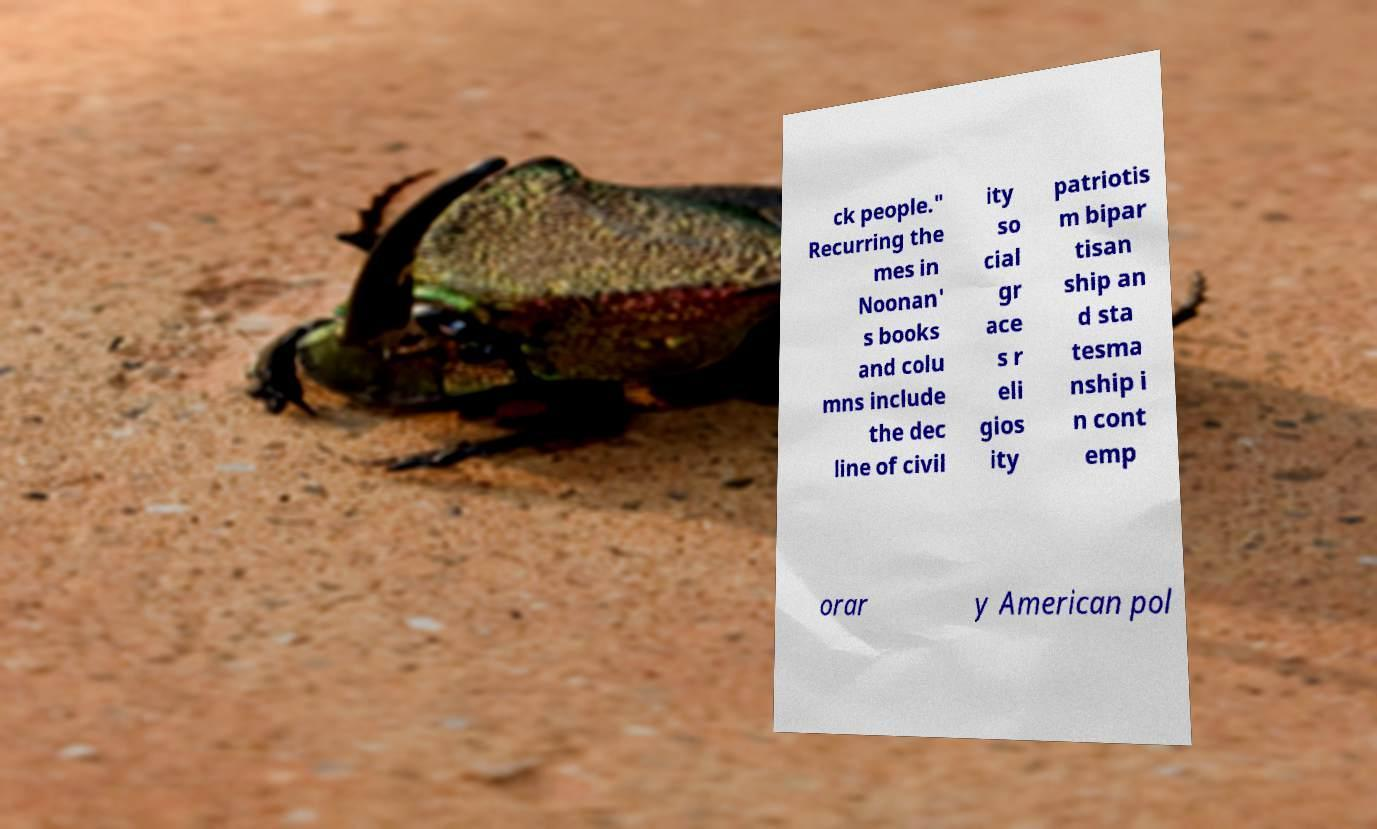Could you assist in decoding the text presented in this image and type it out clearly? ck people." Recurring the mes in Noonan' s books and colu mns include the dec line of civil ity so cial gr ace s r eli gios ity patriotis m bipar tisan ship an d sta tesma nship i n cont emp orar y American pol 